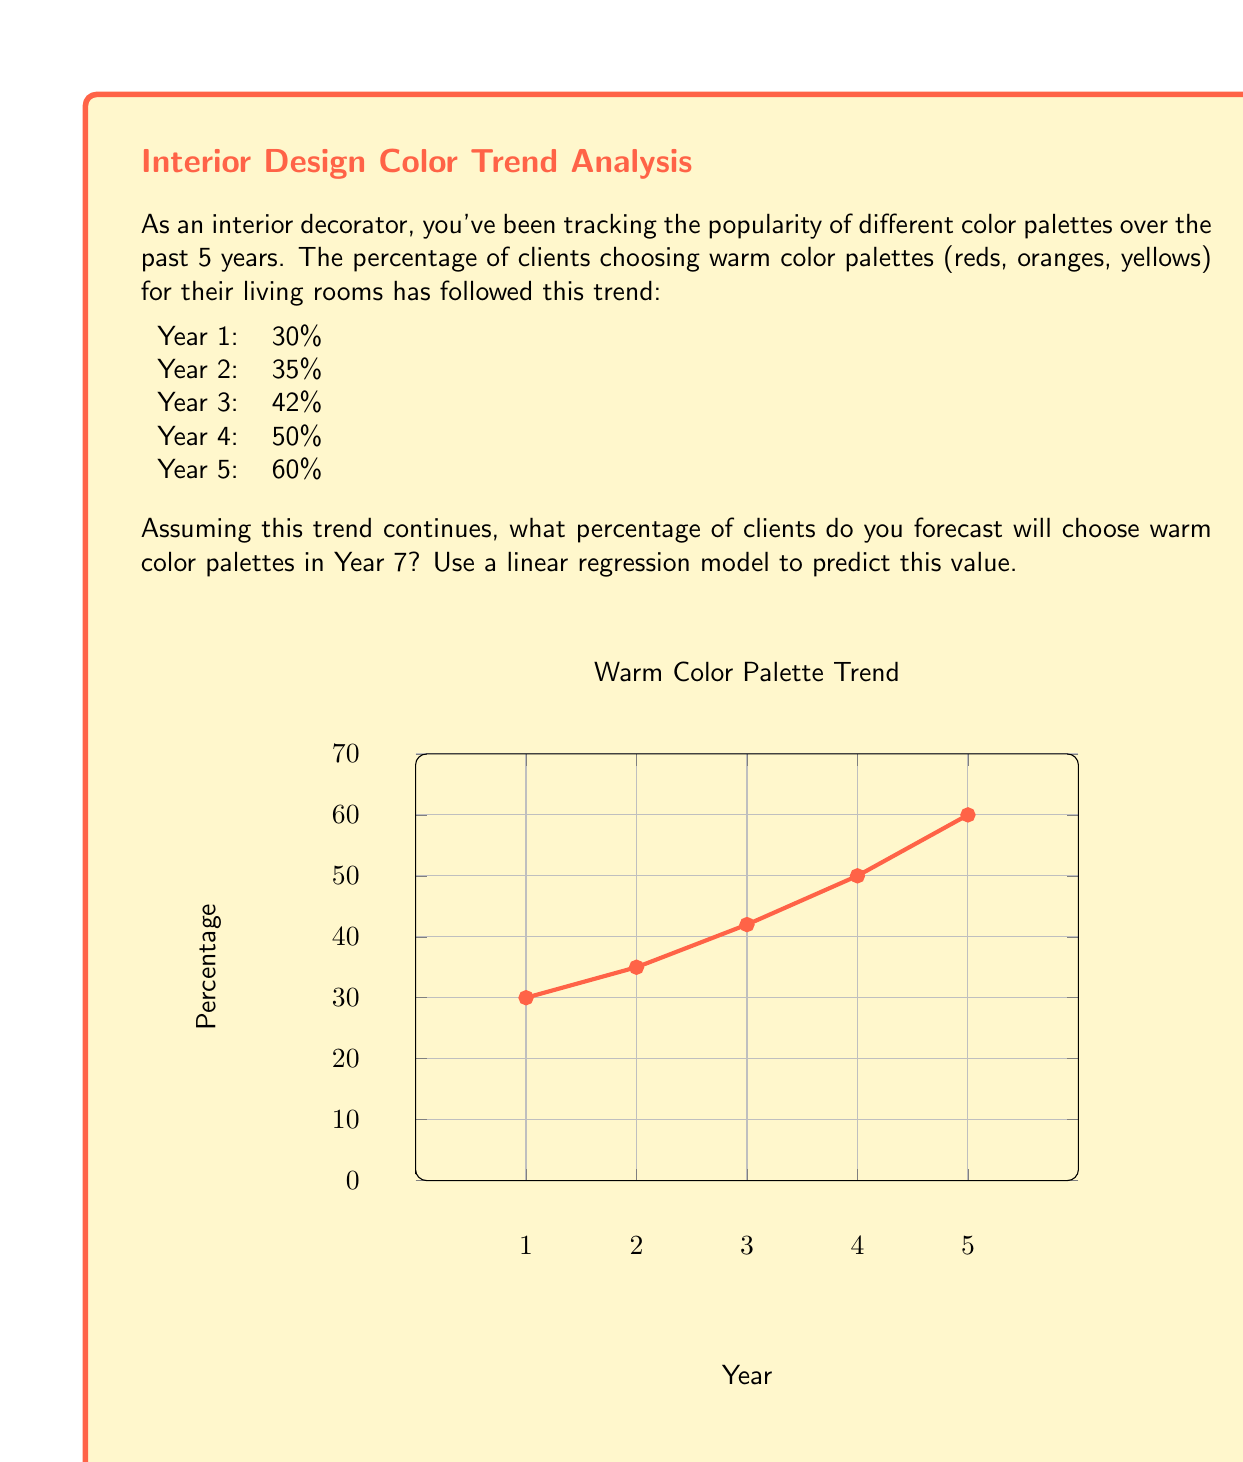Could you help me with this problem? To forecast the percentage for Year 7 using linear regression, we'll follow these steps:

1) First, let's set up our data:
   x (years): 1, 2, 3, 4, 5
   y (percentages): 30, 35, 42, 50, 60

2) We need to calculate the following:
   $\bar{x}$ (mean of x), $\bar{y}$ (mean of y), $\sum xy$, $\sum x^2$

   $\bar{x} = \frac{1+2+3+4+5}{5} = 3$
   $\bar{y} = \frac{30+35+42+50+60}{5} = 43.4$
   $\sum xy = (1)(30) + (2)(35) + (3)(42) + (4)(50) + (5)(60) = 710$
   $\sum x^2 = 1^2 + 2^2 + 3^2 + 4^2 + 5^2 = 55$

3) Now we can calculate the slope (m) and y-intercept (b) of our regression line:

   $m = \frac{n\sum xy - \sum x \sum y}{n\sum x^2 - (\sum x)^2}$
   
   $m = \frac{5(710) - (15)(217)}{5(55) - (15)^2} = \frac{3550 - 3255}{275 - 225} = \frac{295}{50} = 5.9$

   $b = \bar{y} - m\bar{x} = 43.4 - (5.9)(3) = 25.7$

4) Our regression line equation is:
   $y = 5.9x + 25.7$

5) To predict for Year 7, we substitute x = 7:
   $y = 5.9(7) + 25.7 = 67$

Therefore, we forecast that in Year 7, approximately 67% of clients will choose warm color palettes.
Answer: 67% 